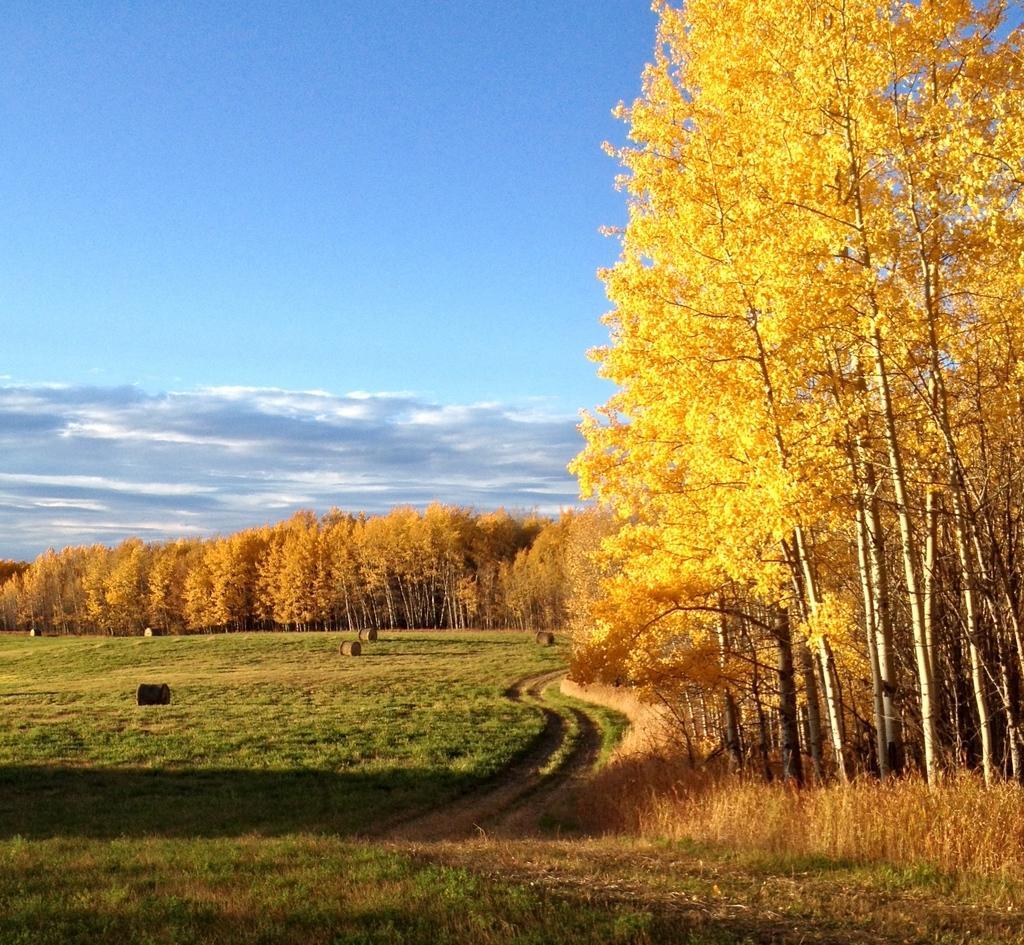How would you summarize this image in a sentence or two? In this image at the bottom we can see grass on the ground and on the right side there are trees on the ground. In the background there are objects on the grass on the ground, trees and clouds in the sky. 